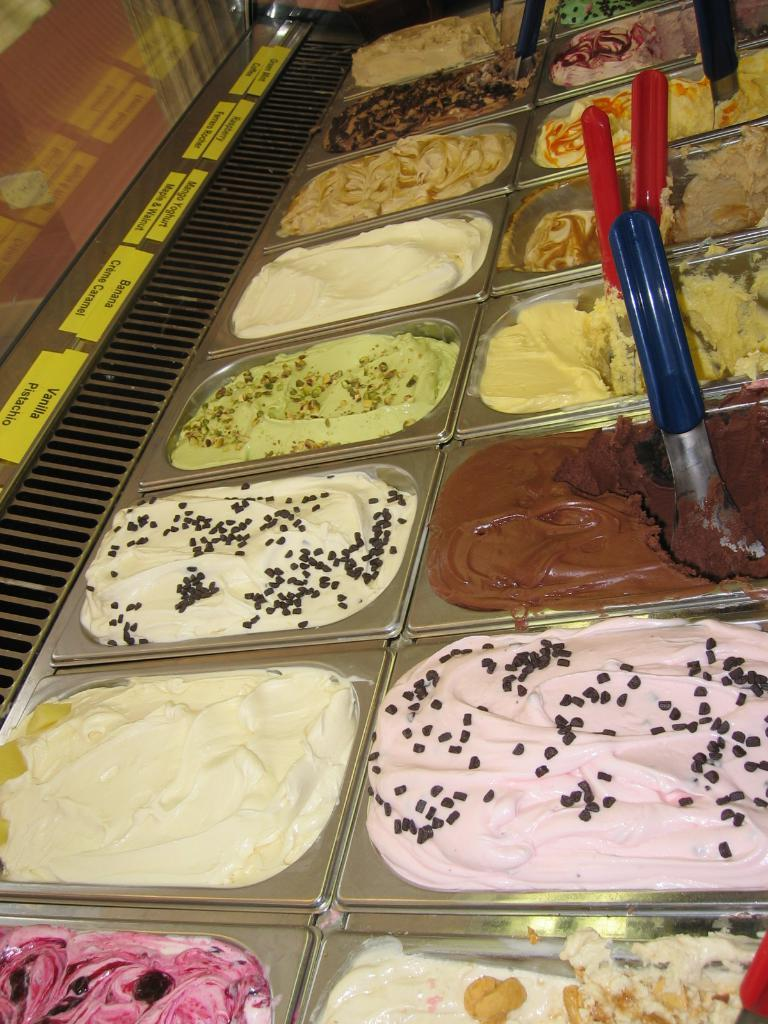What objects are present in the image? There are bowls in the image. What is inside the bowls? The bowls contain different ice creams. How many scoops of ice cream are in each bowl? Each bowl has two scoops of ice cream. What type of form does the family take in the image? There is no family present in the image, only bowls with ice cream. 